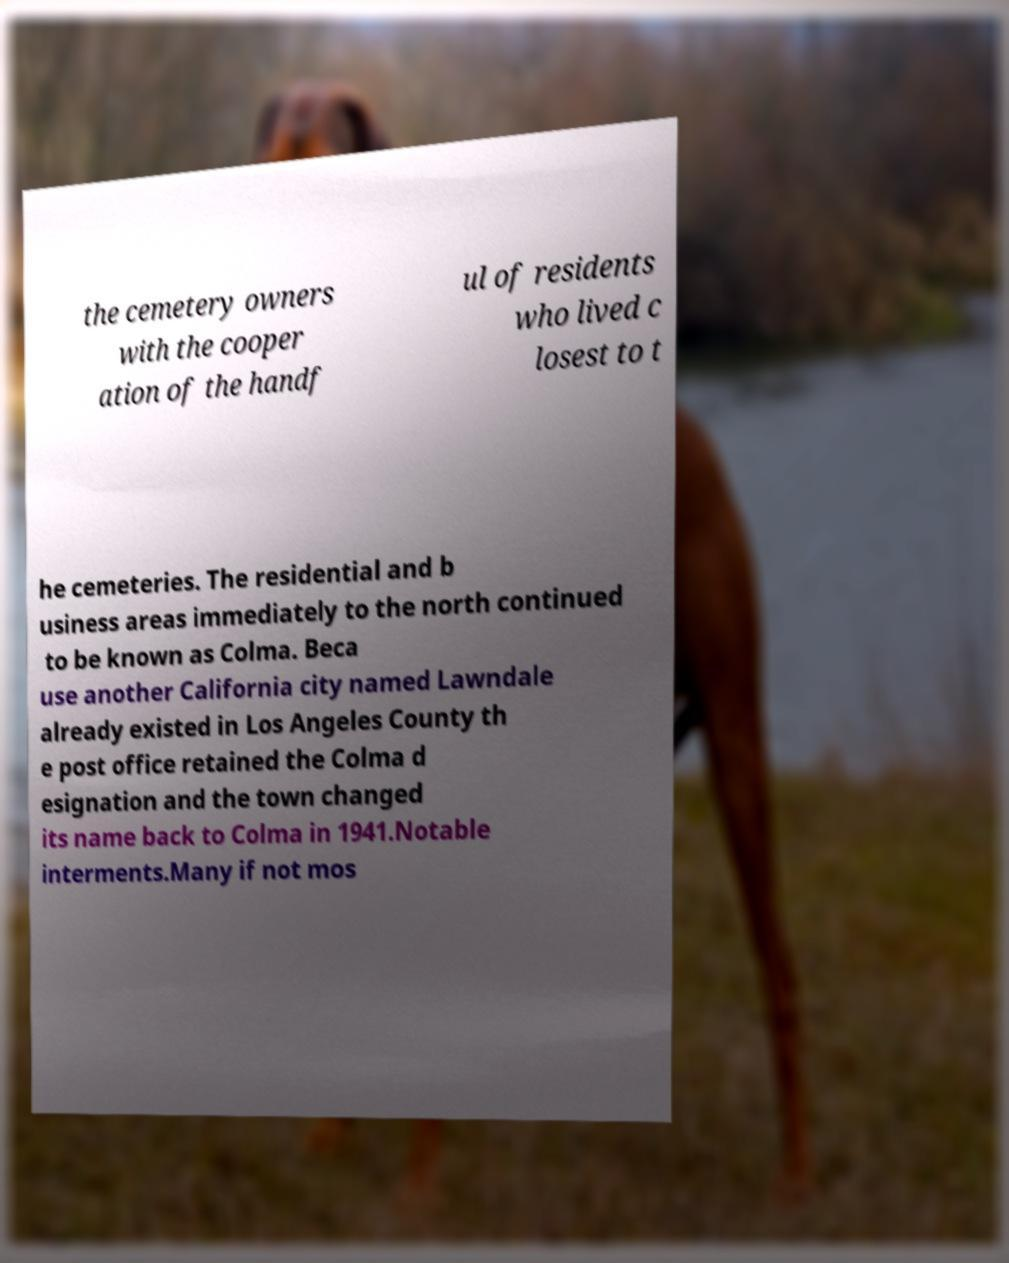I need the written content from this picture converted into text. Can you do that? the cemetery owners with the cooper ation of the handf ul of residents who lived c losest to t he cemeteries. The residential and b usiness areas immediately to the north continued to be known as Colma. Beca use another California city named Lawndale already existed in Los Angeles County th e post office retained the Colma d esignation and the town changed its name back to Colma in 1941.Notable interments.Many if not mos 